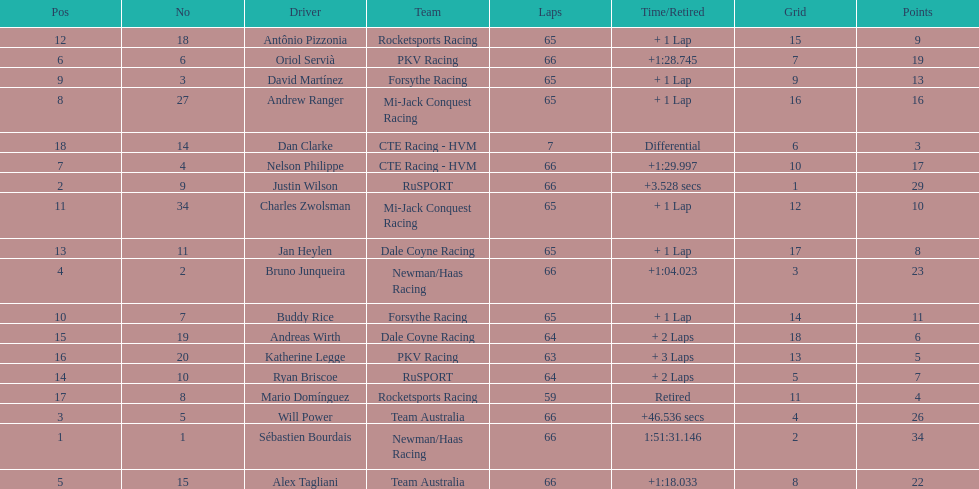How many drivers did not make more than 60 laps? 2. 